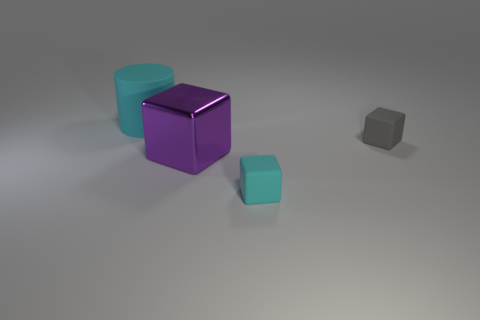Subtract all big metallic cubes. How many cubes are left? 2 Add 2 big matte cylinders. How many objects exist? 6 Subtract 1 cubes. How many cubes are left? 2 Subtract all cyan objects. Subtract all small cyan things. How many objects are left? 1 Add 1 metal things. How many metal things are left? 2 Add 1 small cyan cubes. How many small cyan cubes exist? 2 Subtract all gray cubes. How many cubes are left? 2 Subtract 0 green blocks. How many objects are left? 4 Subtract all cylinders. How many objects are left? 3 Subtract all blue blocks. Subtract all yellow balls. How many blocks are left? 3 